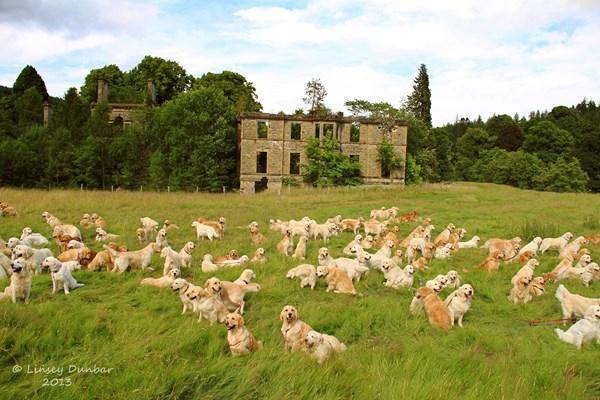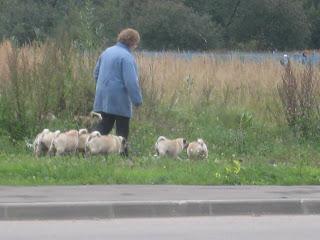The first image is the image on the left, the second image is the image on the right. Given the left and right images, does the statement "There is a person in the image on the right." hold true? Answer yes or no. Yes. The first image is the image on the left, the second image is the image on the right. Given the left and right images, does the statement "In one image, a woman is shown with many little dogs." hold true? Answer yes or no. Yes. 